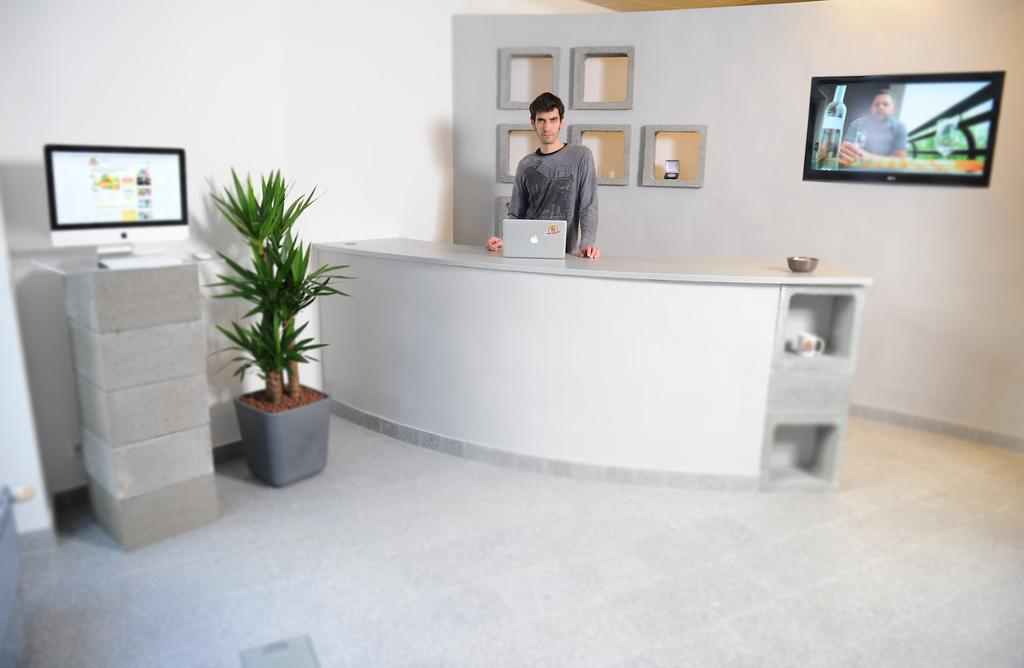What is the person in the image doing? The person is standing near a table. What object is on the table in the image? There is a laptop on the table. What type of plant is visible in the image? There is a house plant system in the image. What electronic device is present in the image? There is an LED screen in the image. How does the person in the image express disgust towards the boat? There is no boat present in the image, and therefore no such expression of disgust can be observed. 